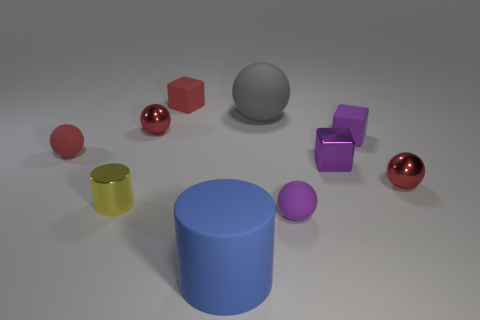There is a matte thing that is left of the matte block on the left side of the small matte thing in front of the yellow thing; what color is it?
Your answer should be very brief. Red. There is a small metallic cube; is its color the same as the rubber cube right of the rubber cylinder?
Give a very brief answer. Yes. What is the color of the large matte ball?
Provide a succinct answer. Gray. What is the shape of the small purple rubber object in front of the small metal sphere on the right side of the large rubber thing that is right of the large blue cylinder?
Offer a terse response. Sphere. How many other objects are the same color as the small metallic cube?
Your answer should be compact. 2. Is the number of red metallic spheres that are behind the tiny purple metallic object greater than the number of purple matte cubes on the left side of the red rubber cube?
Provide a short and direct response. Yes. There is a large gray matte sphere; are there any tiny yellow metal cylinders behind it?
Ensure brevity in your answer.  No. The object that is both right of the gray object and in front of the yellow thing is made of what material?
Your answer should be compact. Rubber. The other object that is the same shape as the blue thing is what color?
Provide a short and direct response. Yellow. There is a red metal object that is on the right side of the purple sphere; is there a red shiny thing that is to the left of it?
Give a very brief answer. Yes. 